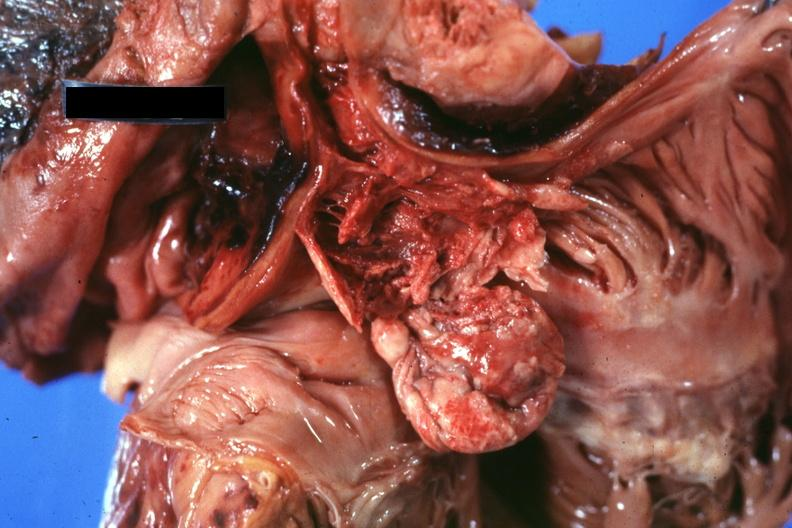s malignant thymoma present?
Answer the question using a single word or phrase. Yes 